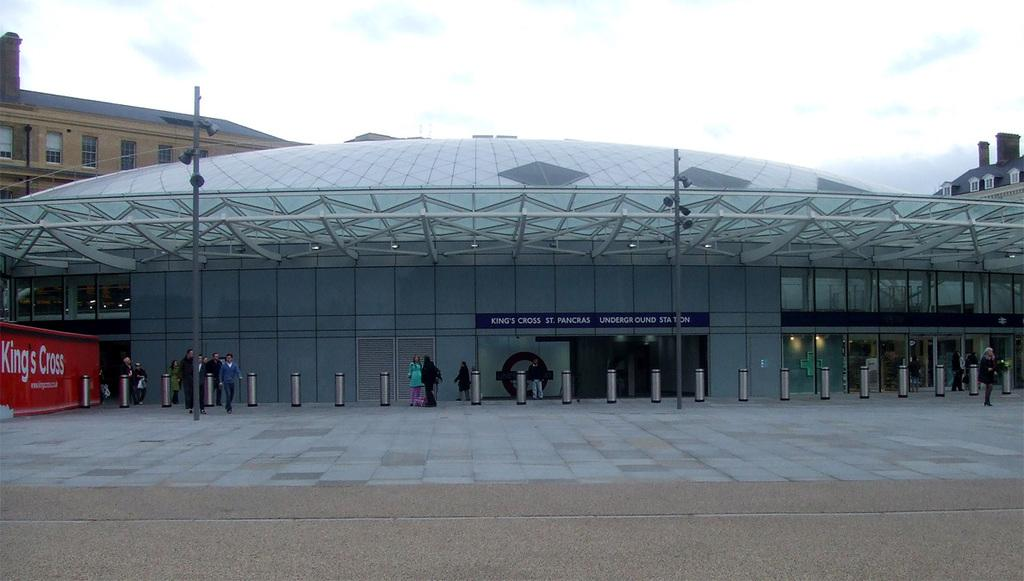How many people are in the image? There are persons in the image, but the exact number is not specified. What can be seen in the image besides the persons? There is a pole and buildings in the image. What is visible in the background of the image? In the background of the image, there are buildings and the sky. What is the condition of the sky in the image? The sky is visible in the background of the image, and clouds are present. What type of behavior is the channel displaying in the image? There is no channel present in the image; it features persons, a pole, buildings, and a sky with clouds. What caption is written on the pole in the image? There is no caption written on the pole in the image; it is just a pole without any text or labels. 